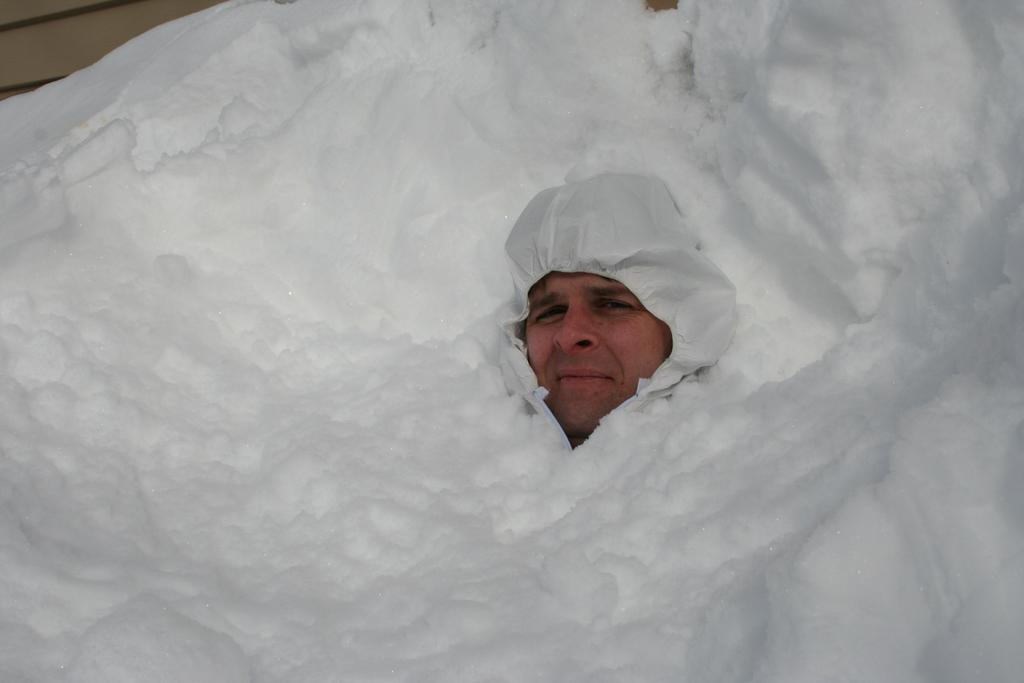Who is present in the image? There is a man in the image. What is the setting of the image? The man appears to be in the snow. What is the man wearing on his head? The man is wearing a white cap. What type of silver kettle is the man holding in the image? There is no kettle, silver or otherwise, present in the image. 